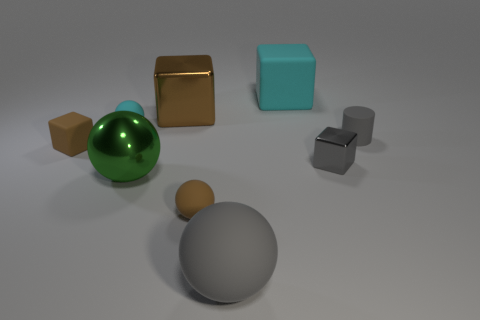How many rubber objects are either big green cylinders or brown objects?
Ensure brevity in your answer.  2. There is a brown thing that is behind the cylinder; is its shape the same as the green object that is behind the brown matte ball?
Keep it short and to the point. No. Is there a tiny blue cube made of the same material as the large green ball?
Ensure brevity in your answer.  No. The tiny cylinder has what color?
Provide a succinct answer. Gray. There is a metal block on the left side of the big gray rubber thing; how big is it?
Keep it short and to the point. Large. What number of tiny rubber spheres have the same color as the small rubber block?
Ensure brevity in your answer.  1. Is there a brown cube in front of the gray matte object to the right of the cyan block?
Give a very brief answer. Yes. There is a metal cube that is in front of the tiny gray rubber cylinder; does it have the same color as the large shiny thing behind the large green metallic object?
Your answer should be very brief. No. What color is the other ball that is the same size as the cyan rubber ball?
Your response must be concise. Brown. Are there an equal number of cyan matte spheres on the left side of the tiny cyan ball and gray spheres to the right of the large cyan block?
Your answer should be very brief. Yes. 